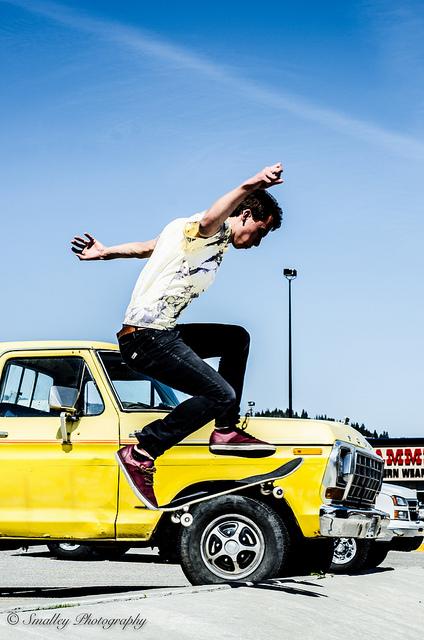Is it safe to jump on a skateboard parked near a car?
Give a very brief answer. No. What color is the truck?
Quick response, please. Yellow. Is that a brand new truck?
Concise answer only. No. Which car is this?
Give a very brief answer. Truck. 